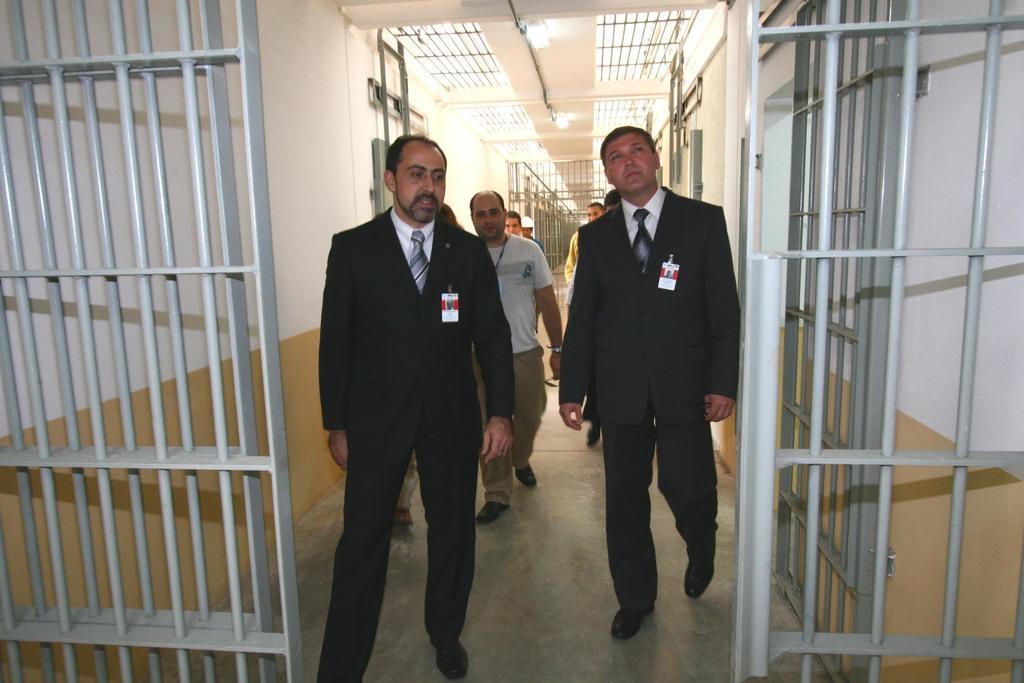Describe this image in one or two sentences. In this picture we can see gates, blazers, ties, id cards, walls and some people walking on the floor and in the background we can see rods, lights and some objects. 